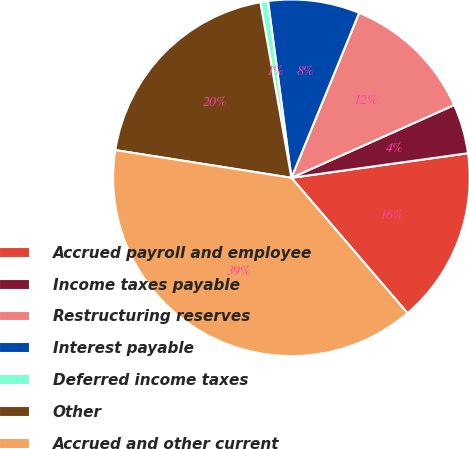Convert chart to OTSL. <chart><loc_0><loc_0><loc_500><loc_500><pie_chart><fcel>Accrued payroll and employee<fcel>Income taxes payable<fcel>Restructuring reserves<fcel>Interest payable<fcel>Deferred income taxes<fcel>Other<fcel>Accrued and other current<nl><fcel>15.92%<fcel>4.49%<fcel>12.11%<fcel>8.3%<fcel>0.69%<fcel>19.73%<fcel>38.77%<nl></chart> 